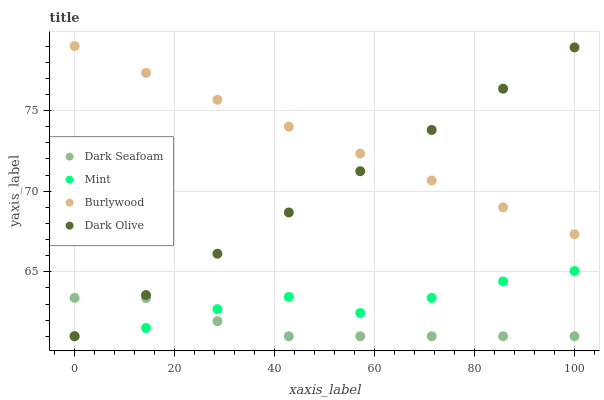Does Dark Seafoam have the minimum area under the curve?
Answer yes or no. Yes. Does Burlywood have the maximum area under the curve?
Answer yes or no. Yes. Does Dark Olive have the minimum area under the curve?
Answer yes or no. No. Does Dark Olive have the maximum area under the curve?
Answer yes or no. No. Is Dark Olive the smoothest?
Answer yes or no. Yes. Is Mint the roughest?
Answer yes or no. Yes. Is Dark Seafoam the smoothest?
Answer yes or no. No. Is Dark Seafoam the roughest?
Answer yes or no. No. Does Dark Seafoam have the lowest value?
Answer yes or no. Yes. Does Burlywood have the highest value?
Answer yes or no. Yes. Does Dark Olive have the highest value?
Answer yes or no. No. Is Mint less than Burlywood?
Answer yes or no. Yes. Is Burlywood greater than Mint?
Answer yes or no. Yes. Does Burlywood intersect Dark Olive?
Answer yes or no. Yes. Is Burlywood less than Dark Olive?
Answer yes or no. No. Is Burlywood greater than Dark Olive?
Answer yes or no. No. Does Mint intersect Burlywood?
Answer yes or no. No. 